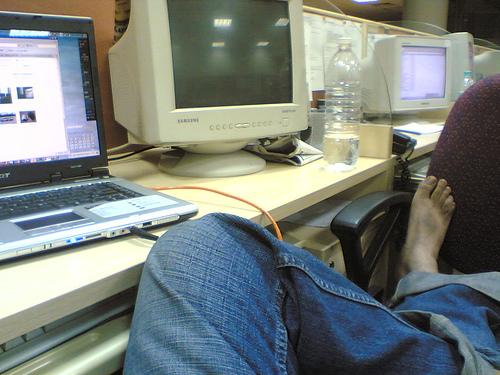What is on the desk?
Quick response, please. Computers. How many laptops are in the photo?
Be succinct. 1. Are they barefoot?
Keep it brief. Yes. 